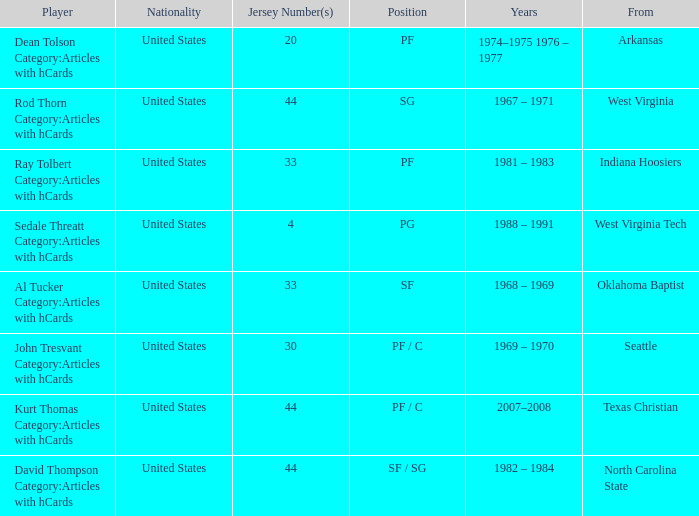Who was the player that was from west virginia tech? Sedale Threatt Category:Articles with hCards. 